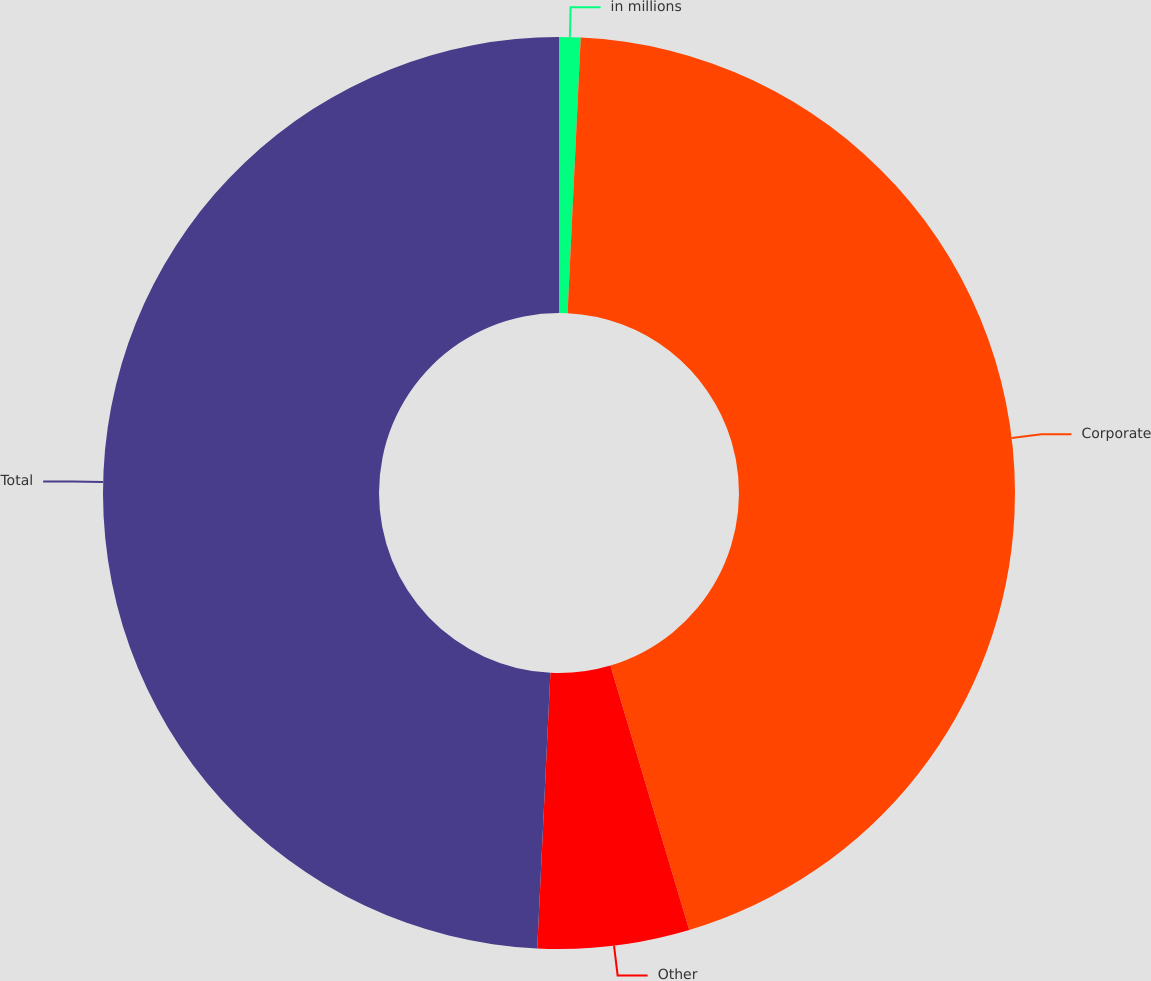<chart> <loc_0><loc_0><loc_500><loc_500><pie_chart><fcel>in millions<fcel>Corporate<fcel>Other<fcel>Total<nl><fcel>0.76%<fcel>44.63%<fcel>5.37%<fcel>49.24%<nl></chart> 